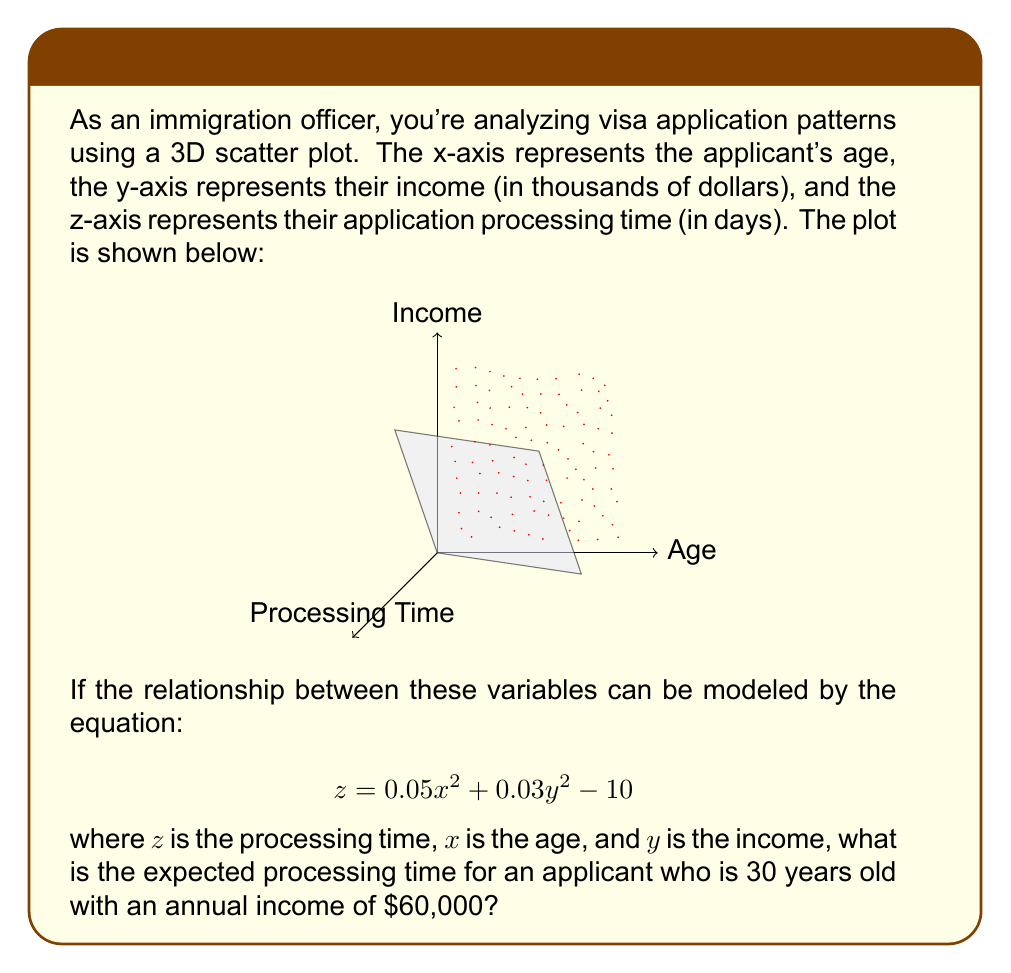Teach me how to tackle this problem. Let's approach this step-by-step:

1) We are given the equation:
   $$z = 0.05x^2 + 0.03y^2 - 10$$

2) We need to find $z$ (processing time) when:
   $x$ (age) = 30
   $y$ (income) = 60

3) First, let's substitute $x = 30$ into the equation:
   $$z = 0.05(30)^2 + 0.03y^2 - 10$$
   $$z = 0.05(900) + 0.03y^2 - 10$$
   $$z = 45 + 0.03y^2 - 10$$
   $$z = 35 + 0.03y^2$$

4) Now, let's substitute $y = 60$ (note that the income is in thousands, so 60 represents $60,000):
   $$z = 35 + 0.03(60)^2$$
   $$z = 35 + 0.03(3600)$$
   $$z = 35 + 108$$
   $$z = 143$$

5) Therefore, the expected processing time is 143 days.
Answer: 143 days 